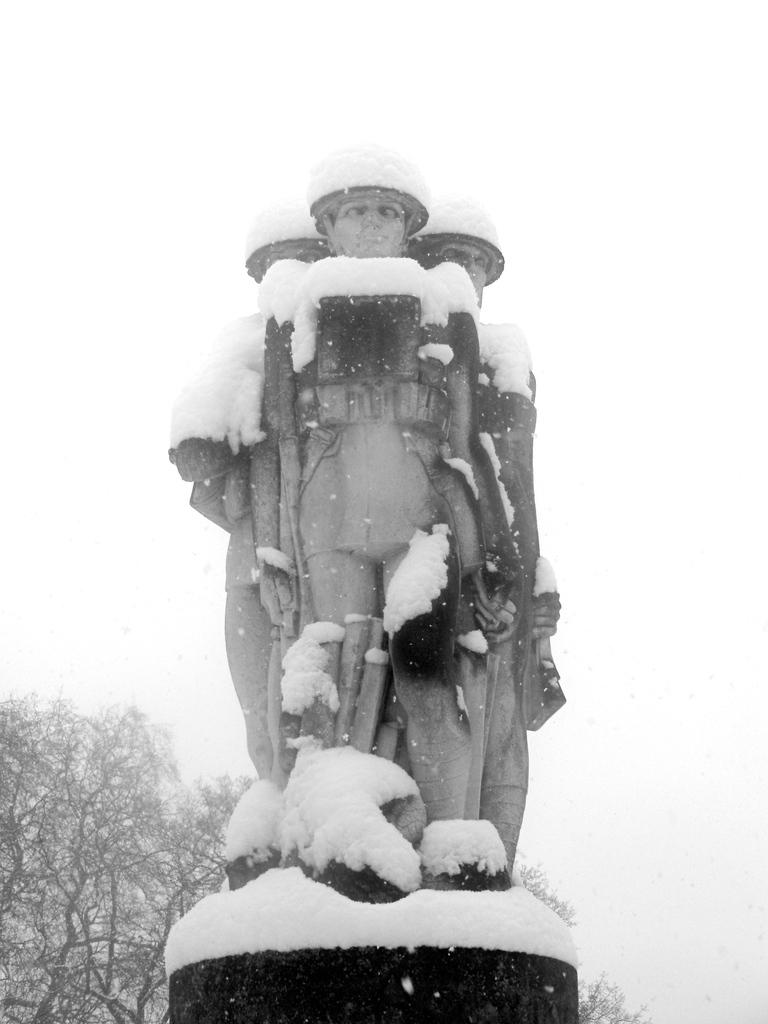What is the color scheme of the image? The image is black and white. What is the main subject in the image? There is a statue in the image. How is the statue positioned in the image? The statue is on a pedestal. What can be seen in the background of the image? There are trees in the background of the image. What is the weather condition in the image? There is snow in the image. How many dinosaurs are visible in the image? There are no dinosaurs present in the image. What type of board is being used by the statue in the image? The statue is not using any board in the image. 